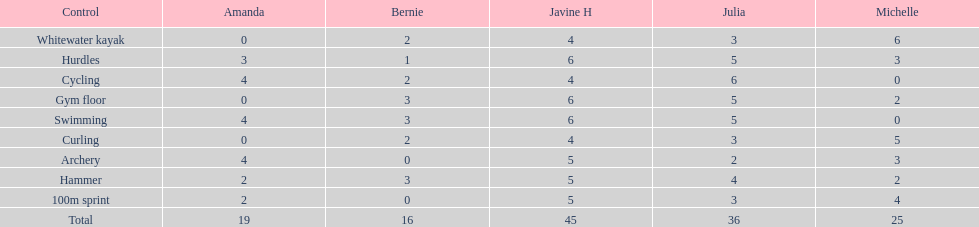What are the number of points bernie scored in hurdles? 1. 